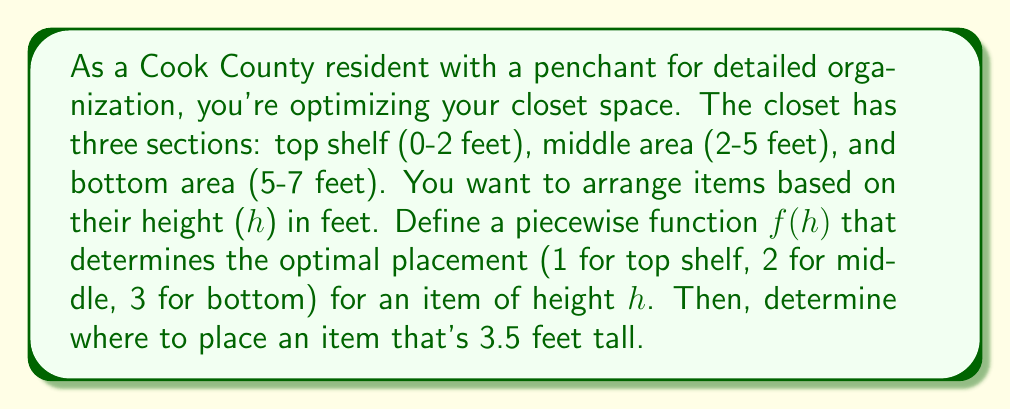Provide a solution to this math problem. 1. First, let's define the piecewise function f(h) based on the given closet sections:

   $$f(h) = \begin{cases}
   1, & 0 \leq h < 2 \\
   2, & 2 \leq h < 5 \\
   3, & 5 \leq h \leq 7
   \end{cases}$$

   Where:
   1 represents the top shelf (0-2 feet)
   2 represents the middle area (2-5 feet)
   3 represents the bottom area (5-7 feet)

2. To determine where to place an item that's 3.5 feet tall, we need to evaluate f(3.5):

3. Since 3.5 is between 2 and 5, it falls in the middle range of our piecewise function:

   $$2 \leq 3.5 < 5$$

4. Therefore, f(3.5) = 2

5. This means an item that's 3.5 feet tall should be placed in the middle area of the closet.
Answer: 2 (middle area) 